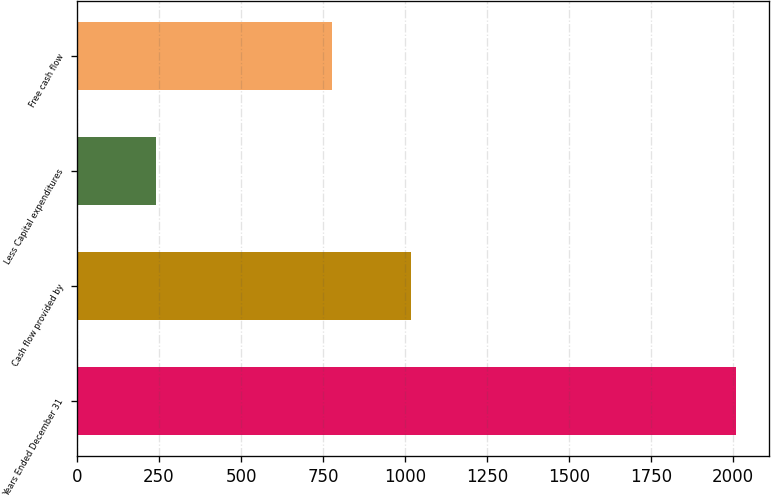<chart> <loc_0><loc_0><loc_500><loc_500><bar_chart><fcel>Years Ended December 31<fcel>Cash flow provided by<fcel>Less Capital expenditures<fcel>Free cash flow<nl><fcel>2011<fcel>1018<fcel>241<fcel>777<nl></chart> 